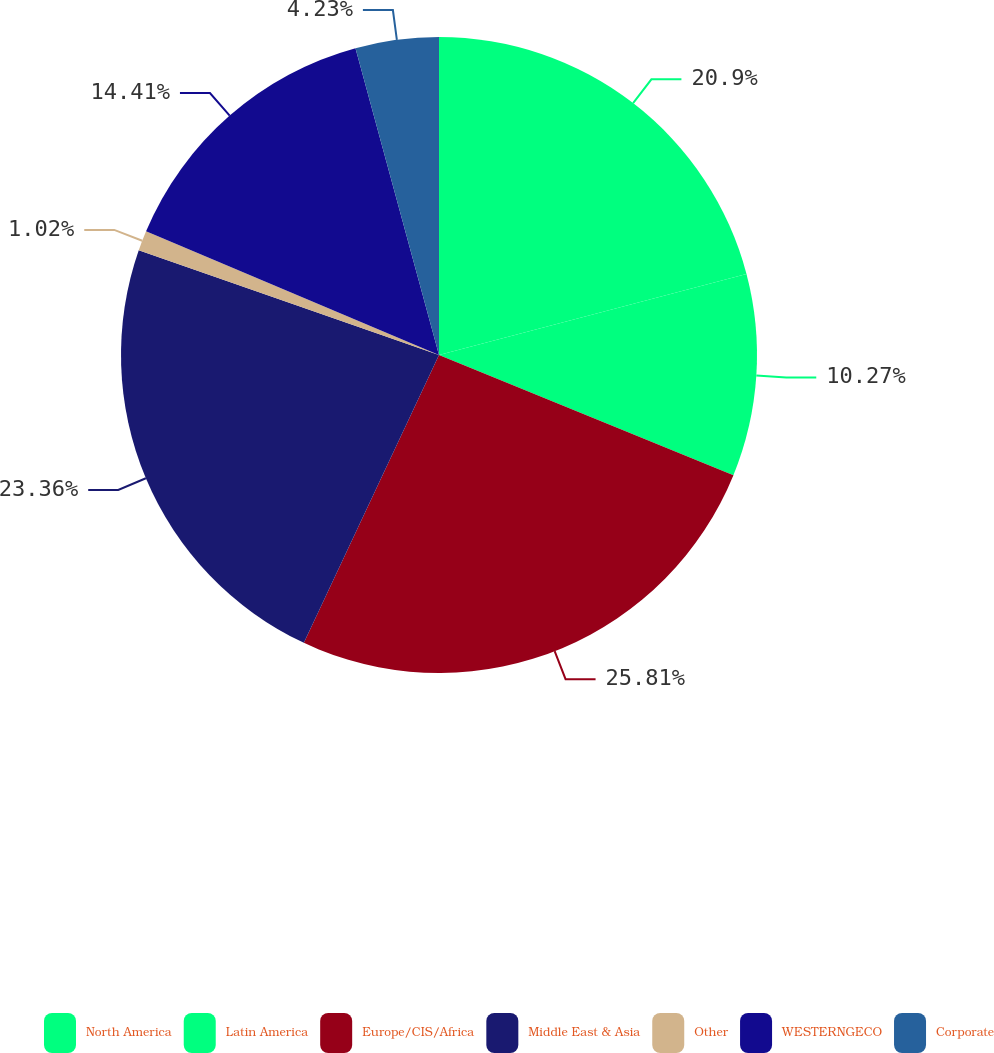<chart> <loc_0><loc_0><loc_500><loc_500><pie_chart><fcel>North America<fcel>Latin America<fcel>Europe/CIS/Africa<fcel>Middle East & Asia<fcel>Other<fcel>WESTERNGECO<fcel>Corporate<nl><fcel>20.9%<fcel>10.27%<fcel>25.82%<fcel>23.36%<fcel>1.02%<fcel>14.41%<fcel>4.23%<nl></chart> 